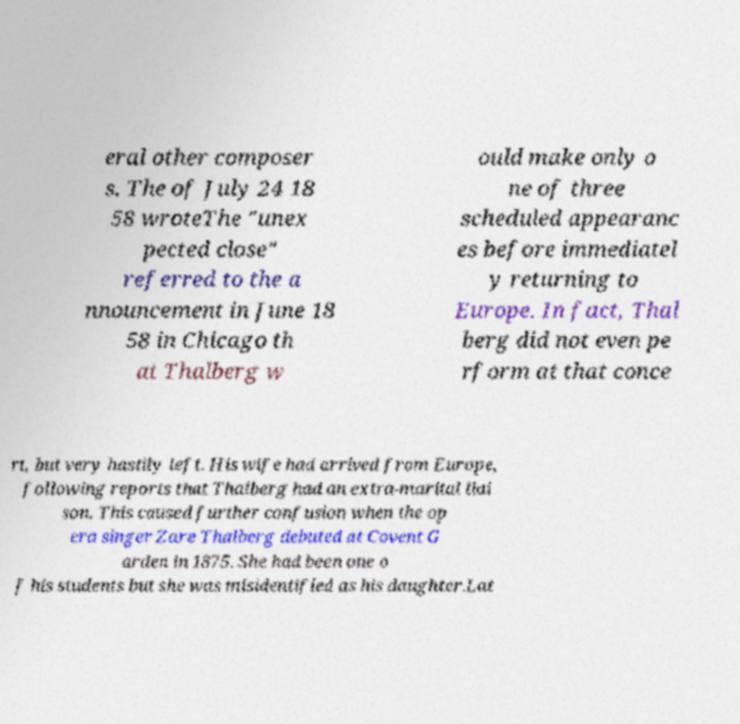Could you assist in decoding the text presented in this image and type it out clearly? eral other composer s. The of July 24 18 58 wroteThe "unex pected close" referred to the a nnouncement in June 18 58 in Chicago th at Thalberg w ould make only o ne of three scheduled appearanc es before immediatel y returning to Europe. In fact, Thal berg did not even pe rform at that conce rt, but very hastily left. His wife had arrived from Europe, following reports that Thalberg had an extra-marital liai son. This caused further confusion when the op era singer Zare Thalberg debuted at Covent G arden in 1875. She had been one o f his students but she was misidentified as his daughter.Lat 